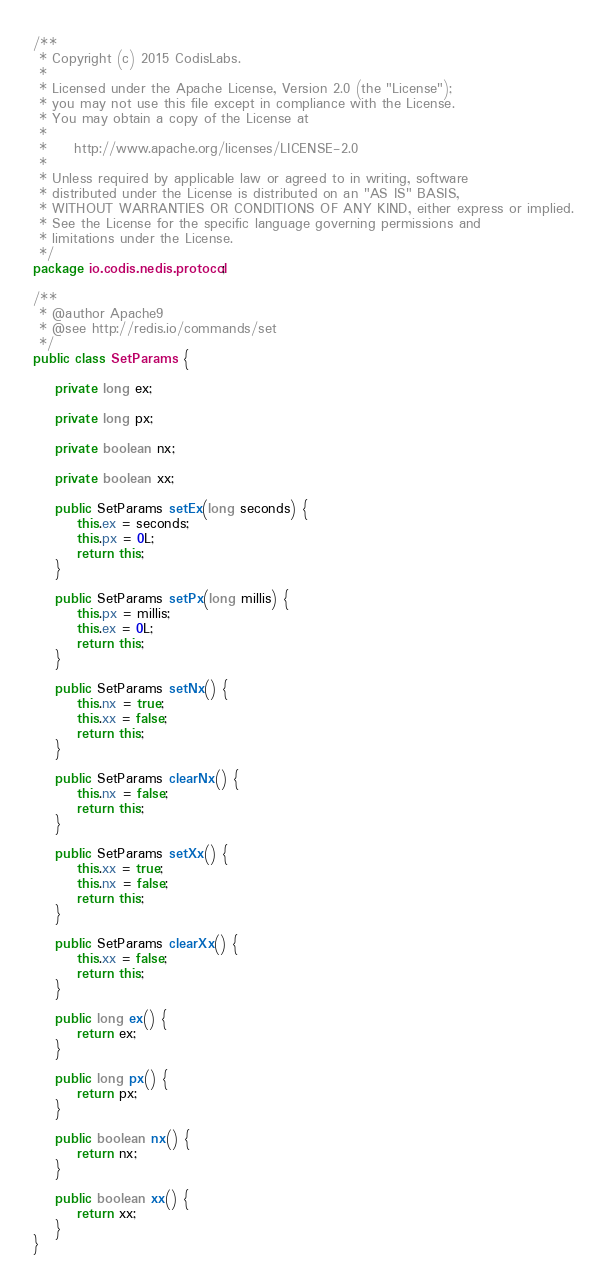Convert code to text. <code><loc_0><loc_0><loc_500><loc_500><_Java_>/**
 * Copyright (c) 2015 CodisLabs.
 *
 * Licensed under the Apache License, Version 2.0 (the "License");
 * you may not use this file except in compliance with the License.
 * You may obtain a copy of the License at
 *
 *     http://www.apache.org/licenses/LICENSE-2.0
 *
 * Unless required by applicable law or agreed to in writing, software
 * distributed under the License is distributed on an "AS IS" BASIS,
 * WITHOUT WARRANTIES OR CONDITIONS OF ANY KIND, either express or implied.
 * See the License for the specific language governing permissions and
 * limitations under the License.
 */
package io.codis.nedis.protocol;

/**
 * @author Apache9
 * @see http://redis.io/commands/set
 */
public class SetParams {

    private long ex;

    private long px;

    private boolean nx;

    private boolean xx;

    public SetParams setEx(long seconds) {
        this.ex = seconds;
        this.px = 0L;
        return this;
    }

    public SetParams setPx(long millis) {
        this.px = millis;
        this.ex = 0L;
        return this;
    }

    public SetParams setNx() {
        this.nx = true;
        this.xx = false;
        return this;
    }

    public SetParams clearNx() {
        this.nx = false;
        return this;
    }

    public SetParams setXx() {
        this.xx = true;
        this.nx = false;
        return this;
    }

    public SetParams clearXx() {
        this.xx = false;
        return this;
    }

    public long ex() {
        return ex;
    }

    public long px() {
        return px;
    }

    public boolean nx() {
        return nx;
    }

    public boolean xx() {
        return xx;
    }
}
</code> 